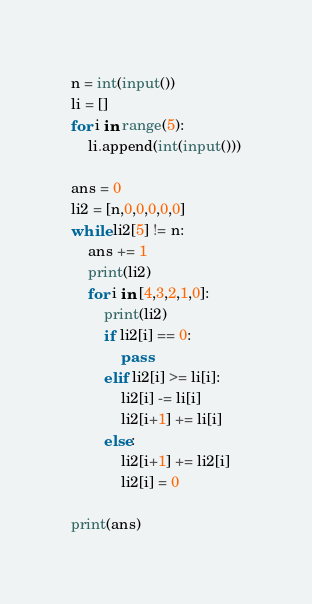Convert code to text. <code><loc_0><loc_0><loc_500><loc_500><_Python_>n = int(input())
li = []
for i in range(5):
    li.append(int(input()))
   
ans = 0
li2 = [n,0,0,0,0,0]
while li2[5] != n:
    ans += 1
    print(li2)
    for i in [4,3,2,1,0]:
        print(li2)
        if li2[i] == 0:
            pass
        elif li2[i] >= li[i]:
            li2[i] -= li[i]
            li2[i+1] += li[i]
        else:
            li2[i+1] += li2[i]
            li2[i] = 0

print(ans)
</code> 